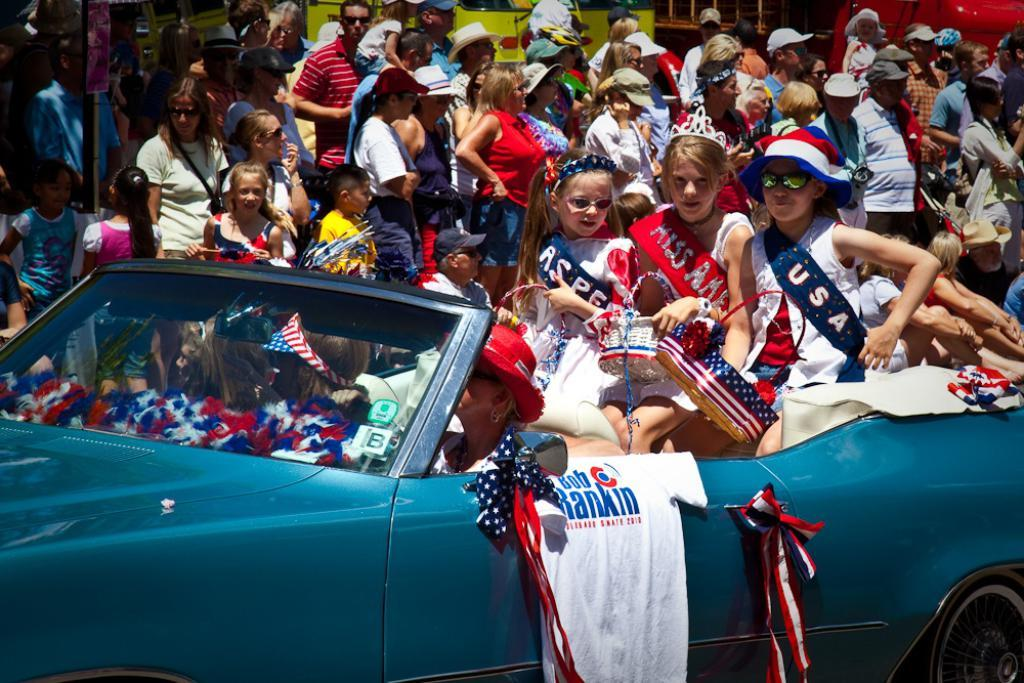What is the main subject of the image? The main subject of the image is a car. Who is riding the car? A woman is riding the car. How many girls are sitting in the car? There are three girls sitting in the car. What are the people in the background doing? The people in the background are watching a show. What letters does the woman's aunt send her in the image? There is no mention of letters or an aunt in the image, so we cannot answer this question. 